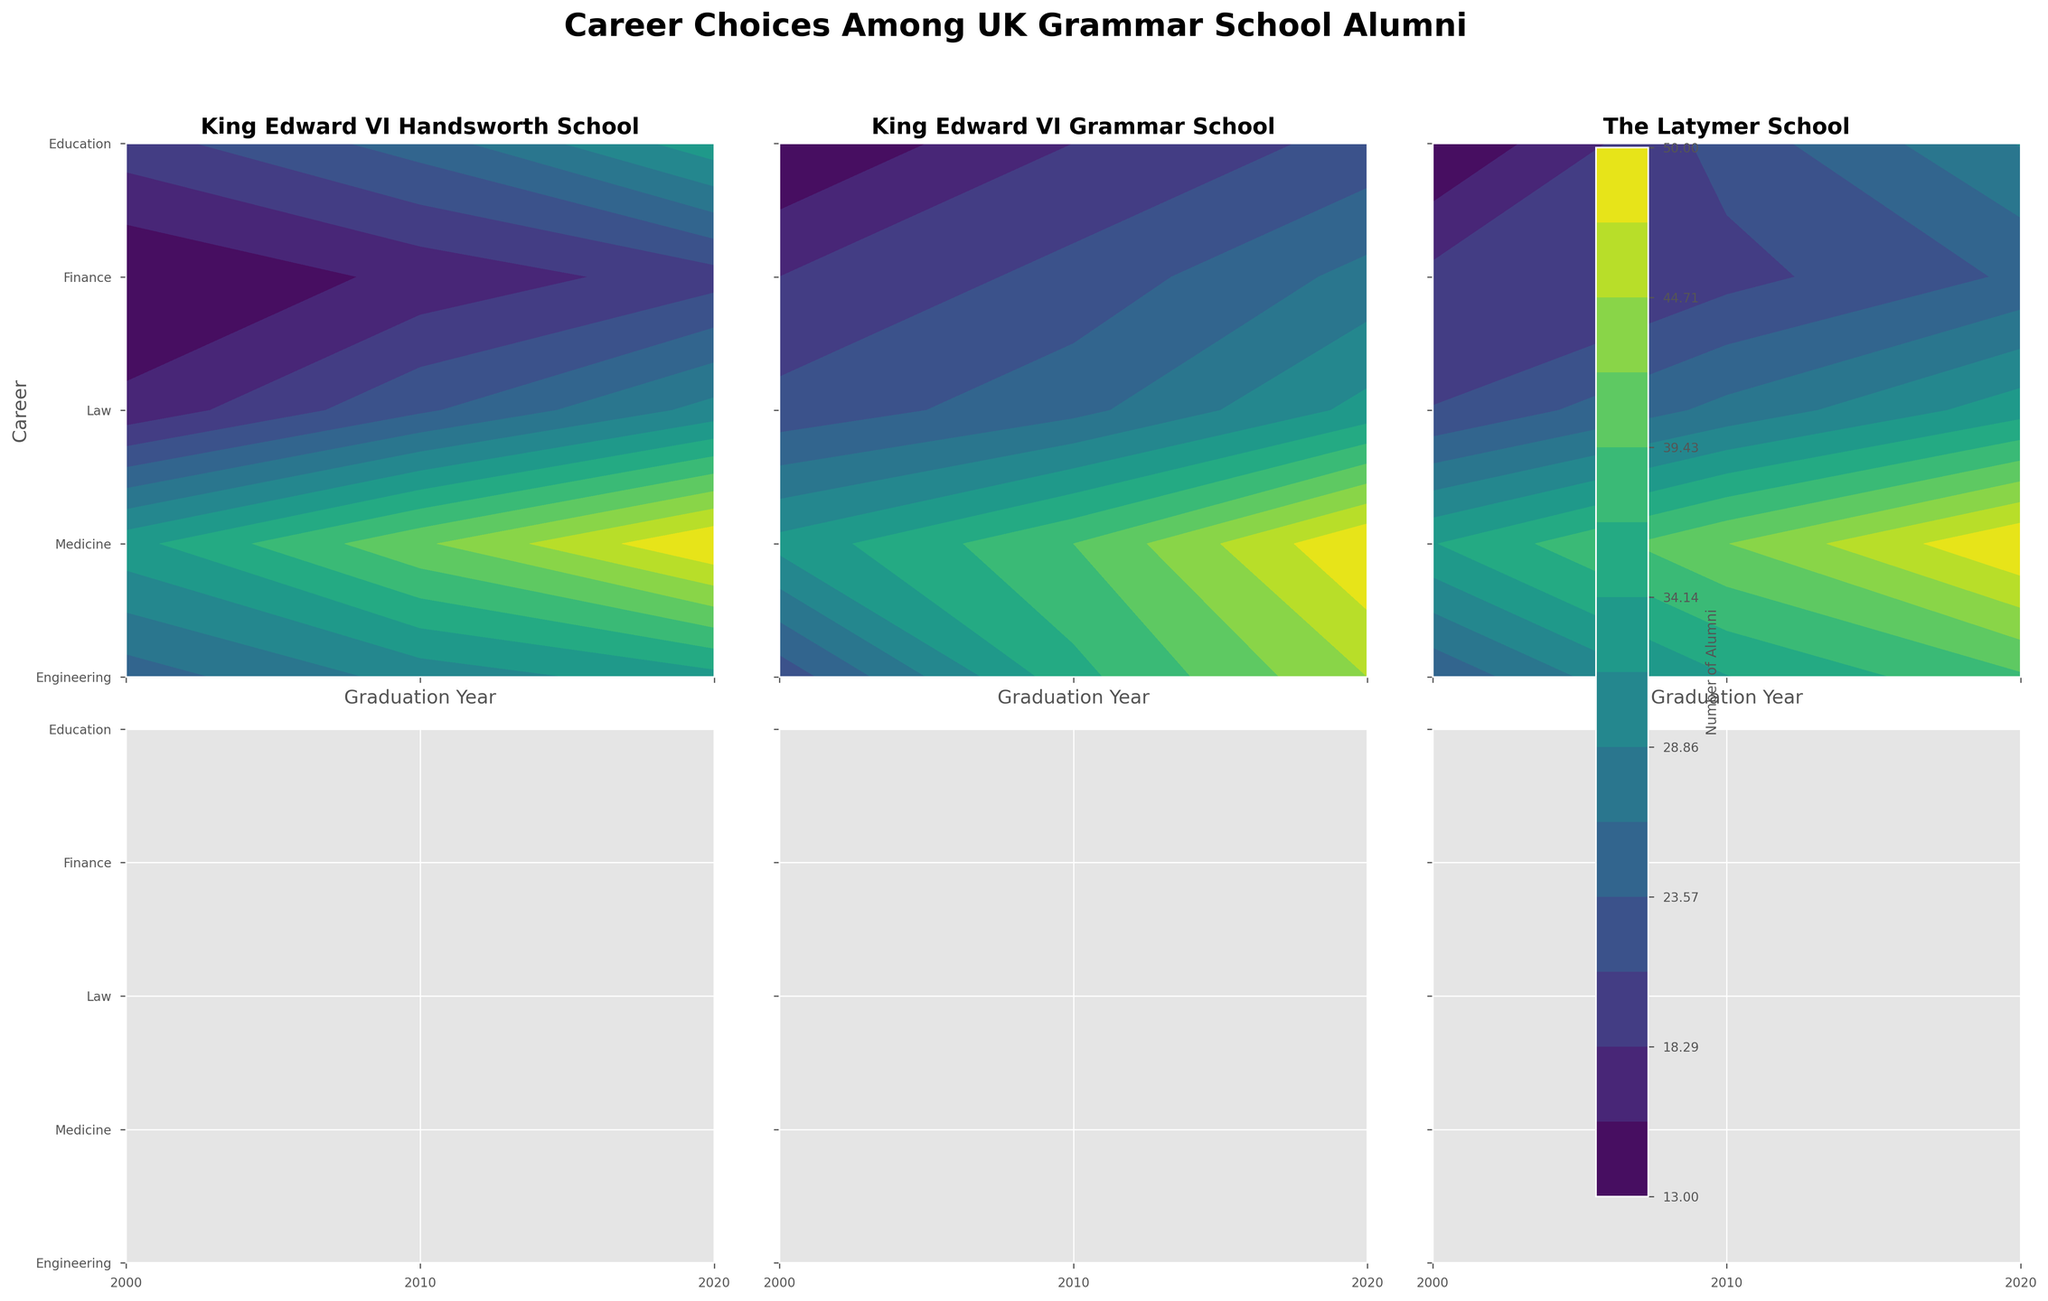Which career has the highest number of alumni from King Edward VI Handsworth School in 2020? Look at the panel labeled 'King Edward VI Handsworth School' in the column for the year 2020 and identify which contour level is the highest for each career. The highest contour level corresponds to Medicine.
Answer: Medicine What is the trend in the number of alumni opting for Engineering careers at King Edward VI Grammar School from 2000 to 2020? In the 'King Edward VI Grammar School' panel, examine the contour levels for Engineering from the year 2000 to 2020. Notice the transition from lighter to darker shades, indicating an increase.
Answer: Increasing Which school has more alumni in Finance careers in 2010, King Edward VI Grammar School or The Latymer School? Contrast the levels of the contour filled areas for Finance careers in the 2010 column for both 'King Edward VI Grammar School' and 'The Latymer School'. The levels for King Edward VI Grammar School are higher.
Answer: King Edward VI Grammar School Between King Edward VI Handsworth School and The Latymer School, which produced a higher number of female alumni in Education careers in 2020? Compare the 'King Edward VI Handsworth School' and 'The Latymer School' panels under the 2020 column for the countours in Education. King Edward VI Handsworth School has a higher contour level.
Answer: King Edward VI Handsworth School How has the number of alumni from The Latymer School pursuing Medicine changed from 2000 to 2020? In The Latymer School panel, look at the contour levels for Medicine over the years 2000, 2010, and 2020. The contour levels increase significantly suggesting more alumni are pursuing Medicine.
Answer: Increased What is the most popular career choice for female alumni of The Latymer School in 2010? In the 'The Latymer School' panel, under the 2010 column, identify the career with the highest contour level among female alumni. The darkest shade corresponds to Medicine.
Answer: Medicine Which school has the least number of alumni entering Law careers in 2000? Look at the mildest (lightest) contour level for Law careers in the 2000 column across all school panels. "The Latymer School" has the lowest level.
Answer: The Latymer School 